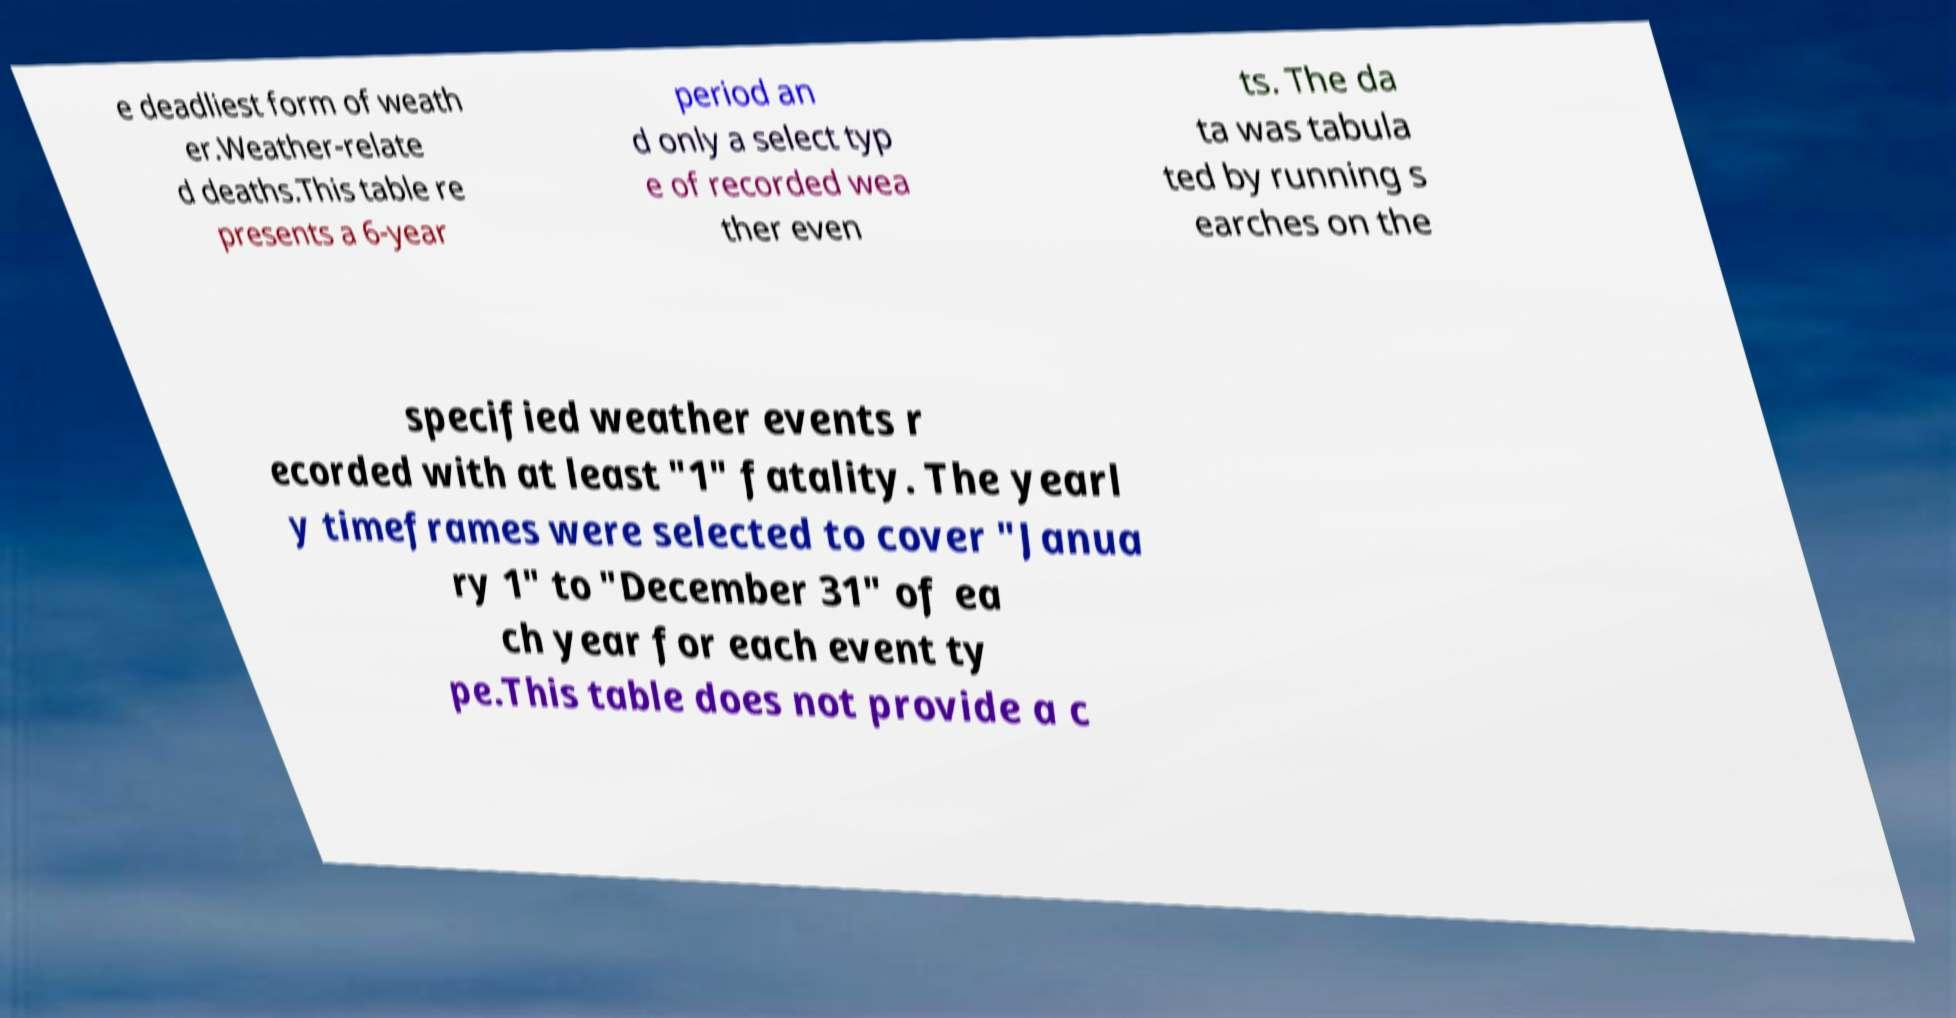Could you extract and type out the text from this image? e deadliest form of weath er.Weather-relate d deaths.This table re presents a 6-year period an d only a select typ e of recorded wea ther even ts. The da ta was tabula ted by running s earches on the specified weather events r ecorded with at least "1" fatality. The yearl y timeframes were selected to cover "Janua ry 1" to "December 31" of ea ch year for each event ty pe.This table does not provide a c 